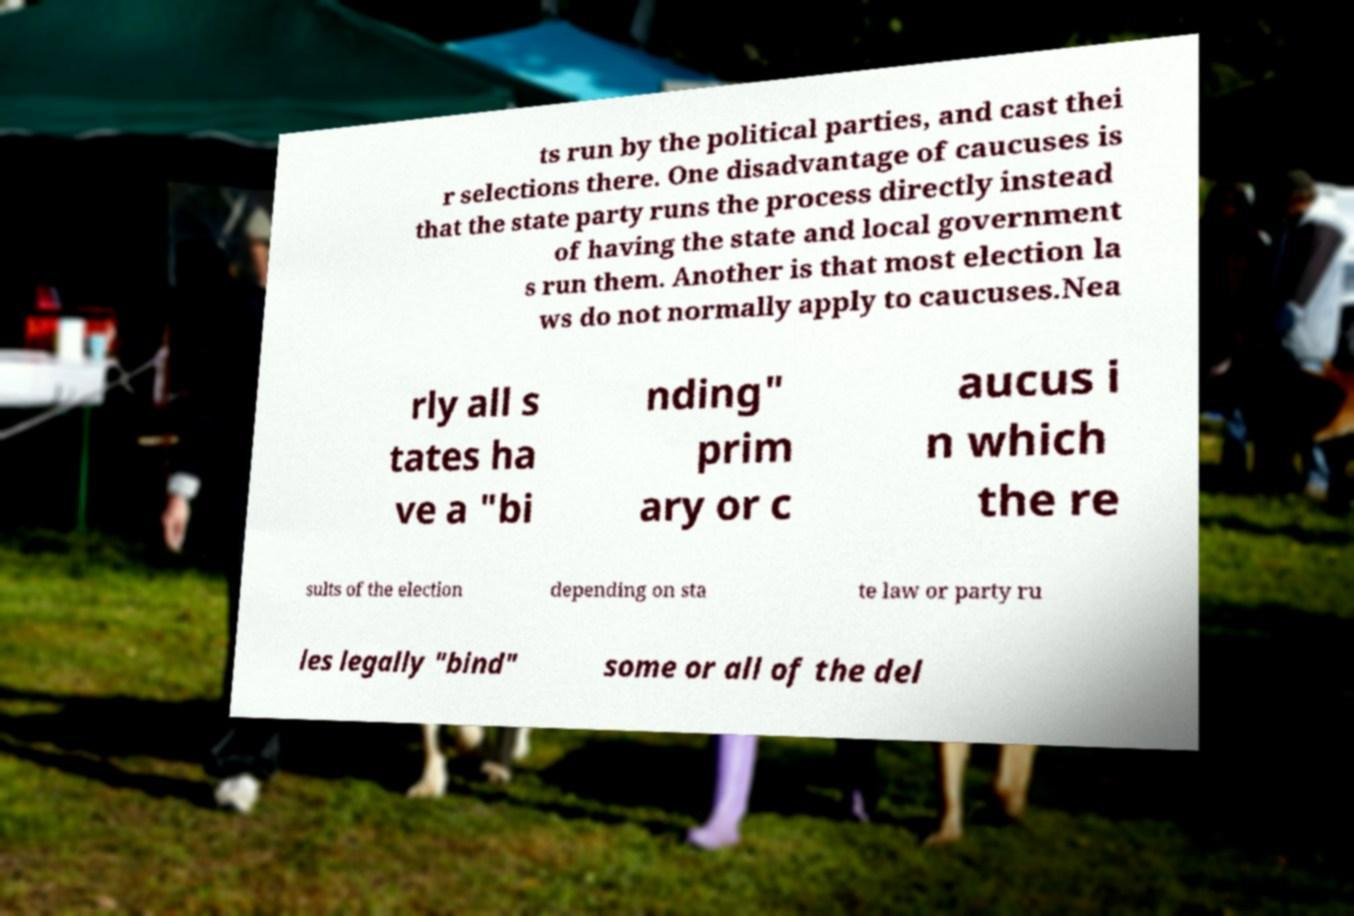I need the written content from this picture converted into text. Can you do that? ts run by the political parties, and cast thei r selections there. One disadvantage of caucuses is that the state party runs the process directly instead of having the state and local government s run them. Another is that most election la ws do not normally apply to caucuses.Nea rly all s tates ha ve a "bi nding" prim ary or c aucus i n which the re sults of the election depending on sta te law or party ru les legally "bind" some or all of the del 